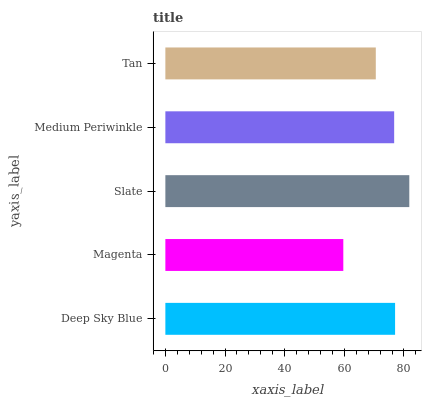Is Magenta the minimum?
Answer yes or no. Yes. Is Slate the maximum?
Answer yes or no. Yes. Is Slate the minimum?
Answer yes or no. No. Is Magenta the maximum?
Answer yes or no. No. Is Slate greater than Magenta?
Answer yes or no. Yes. Is Magenta less than Slate?
Answer yes or no. Yes. Is Magenta greater than Slate?
Answer yes or no. No. Is Slate less than Magenta?
Answer yes or no. No. Is Medium Periwinkle the high median?
Answer yes or no. Yes. Is Medium Periwinkle the low median?
Answer yes or no. Yes. Is Slate the high median?
Answer yes or no. No. Is Deep Sky Blue the low median?
Answer yes or no. No. 